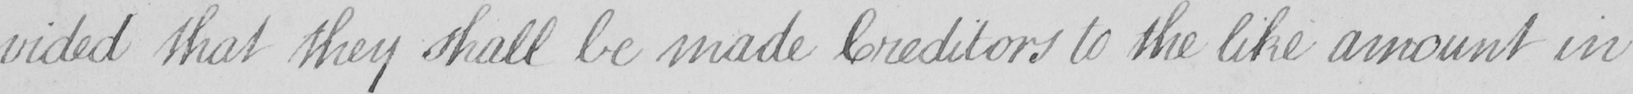Can you tell me what this handwritten text says? -vided that they shall be made Creditors to the like amount in 